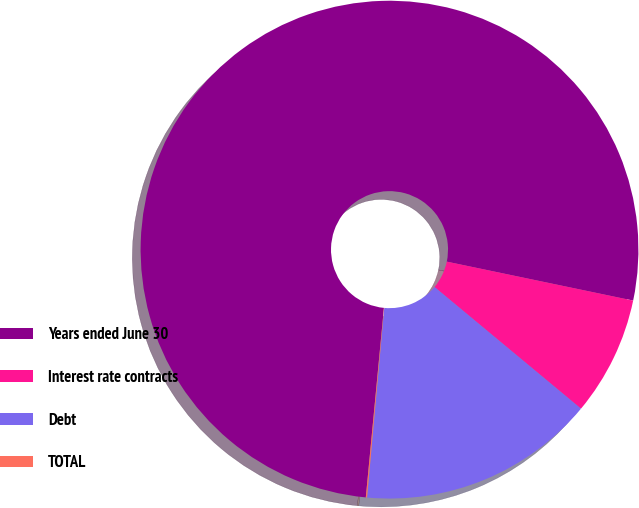Convert chart to OTSL. <chart><loc_0><loc_0><loc_500><loc_500><pie_chart><fcel>Years ended June 30<fcel>Interest rate contracts<fcel>Debt<fcel>TOTAL<nl><fcel>76.76%<fcel>7.75%<fcel>15.41%<fcel>0.08%<nl></chart> 